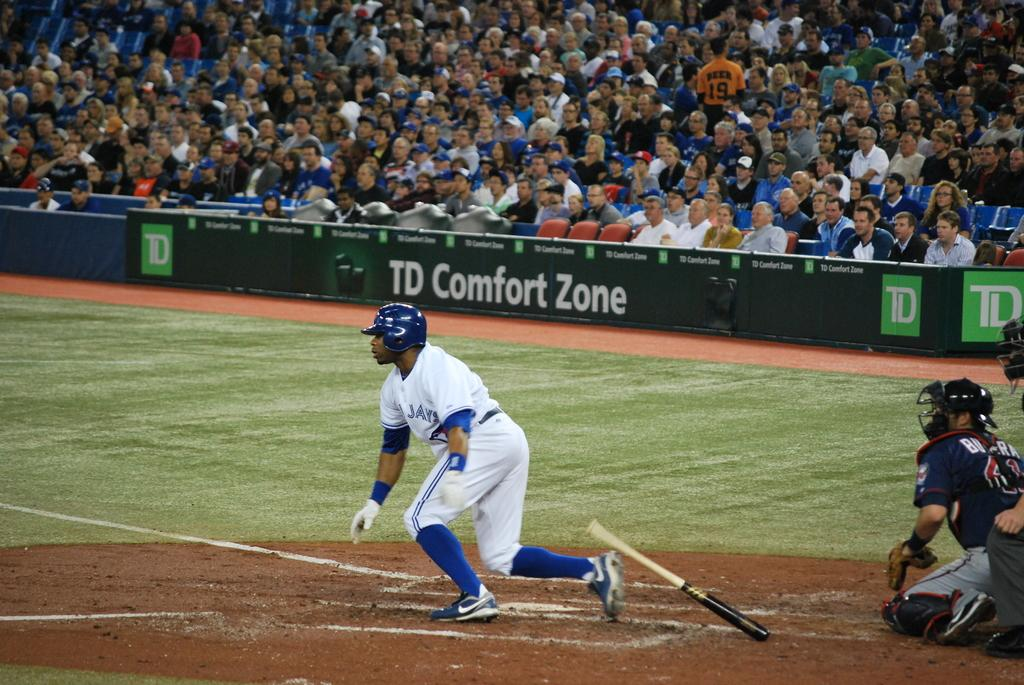<image>
Offer a succinct explanation of the picture presented. one of the sponsors of the game is TD Comfort Zone 